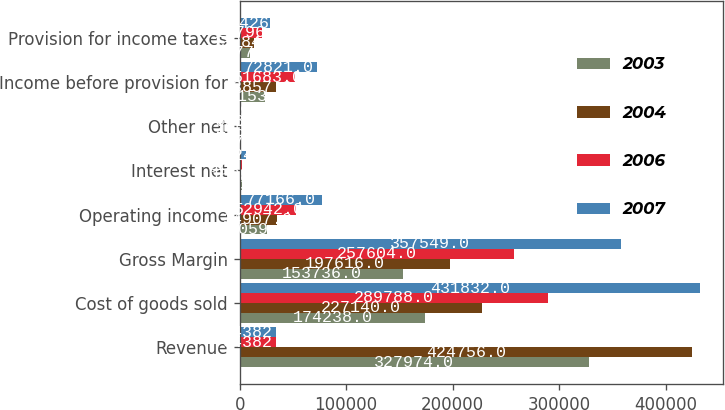Convert chart to OTSL. <chart><loc_0><loc_0><loc_500><loc_500><stacked_bar_chart><ecel><fcel>Revenue<fcel>Cost of goods sold<fcel>Gross Margin<fcel>Operating income<fcel>Interest net<fcel>Other net<fcel>Income before provision for<fcel>Provision for income taxes<nl><fcel>2003<fcel>327974<fcel>174238<fcel>153736<fcel>26059<fcel>2023<fcel>117<fcel>24153<fcel>9577<nl><fcel>2004<fcel>424756<fcel>227140<fcel>197616<fcel>34907<fcel>1505<fcel>455<fcel>33857<fcel>13284<nl><fcel>2006<fcel>34382<fcel>289788<fcel>257604<fcel>52942<fcel>1887<fcel>628<fcel>51683<fcel>20796<nl><fcel>2007<fcel>34382<fcel>431832<fcel>357549<fcel>77166<fcel>5824<fcel>1479<fcel>72821<fcel>28426<nl></chart> 